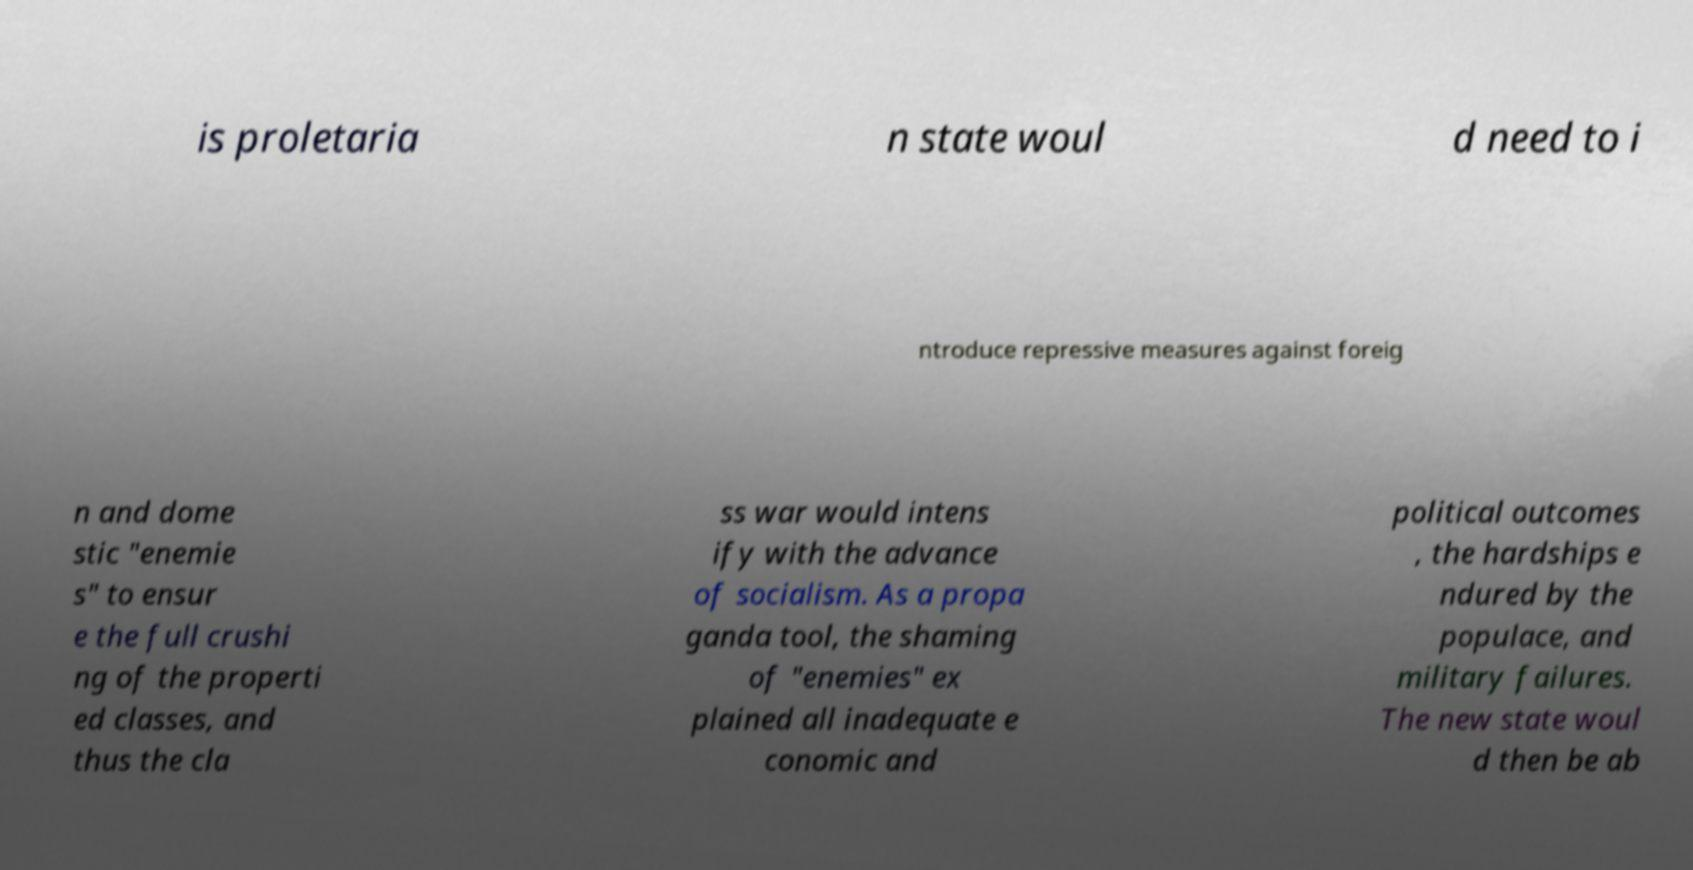I need the written content from this picture converted into text. Can you do that? is proletaria n state woul d need to i ntroduce repressive measures against foreig n and dome stic "enemie s" to ensur e the full crushi ng of the properti ed classes, and thus the cla ss war would intens ify with the advance of socialism. As a propa ganda tool, the shaming of "enemies" ex plained all inadequate e conomic and political outcomes , the hardships e ndured by the populace, and military failures. The new state woul d then be ab 